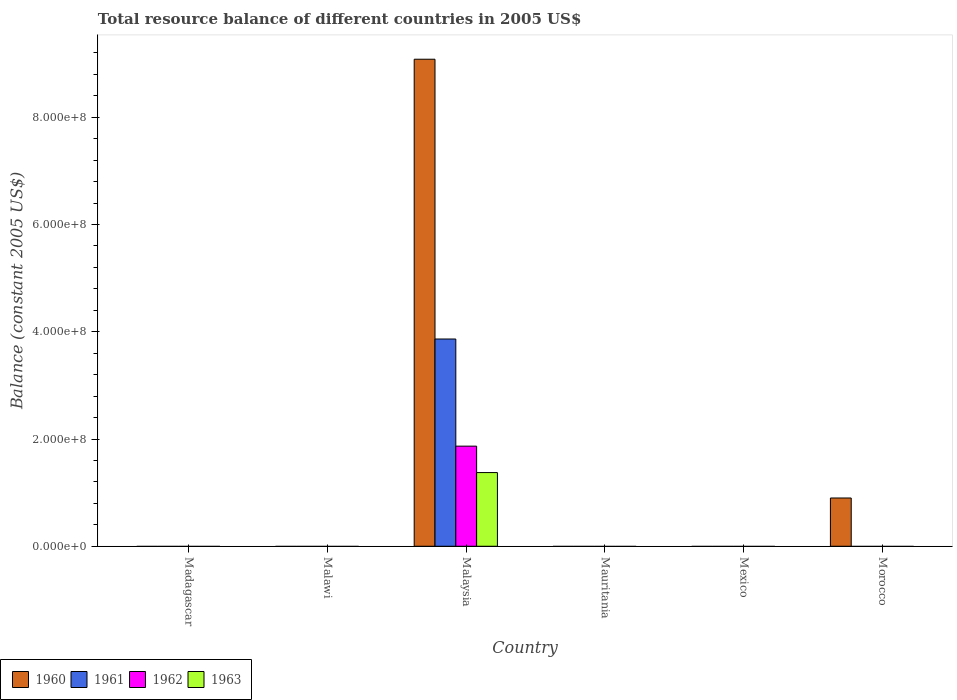Are the number of bars on each tick of the X-axis equal?
Your answer should be very brief. No. How many bars are there on the 1st tick from the left?
Give a very brief answer. 0. What is the label of the 1st group of bars from the left?
Provide a succinct answer. Madagascar. In how many cases, is the number of bars for a given country not equal to the number of legend labels?
Your response must be concise. 5. What is the total resource balance in 1960 in Morocco?
Provide a short and direct response. 9.00e+07. Across all countries, what is the maximum total resource balance in 1962?
Your response must be concise. 1.87e+08. Across all countries, what is the minimum total resource balance in 1962?
Your response must be concise. 0. In which country was the total resource balance in 1960 maximum?
Your answer should be compact. Malaysia. What is the total total resource balance in 1961 in the graph?
Your answer should be very brief. 3.87e+08. What is the average total resource balance in 1963 per country?
Your response must be concise. 2.29e+07. In how many countries, is the total resource balance in 1961 greater than 440000000 US$?
Your response must be concise. 0. What is the difference between the highest and the lowest total resource balance in 1961?
Your answer should be very brief. 3.87e+08. In how many countries, is the total resource balance in 1960 greater than the average total resource balance in 1960 taken over all countries?
Your answer should be compact. 1. Are all the bars in the graph horizontal?
Keep it short and to the point. No. How many countries are there in the graph?
Your answer should be compact. 6. What is the difference between two consecutive major ticks on the Y-axis?
Offer a very short reply. 2.00e+08. Are the values on the major ticks of Y-axis written in scientific E-notation?
Offer a terse response. Yes. Does the graph contain any zero values?
Give a very brief answer. Yes. Where does the legend appear in the graph?
Ensure brevity in your answer.  Bottom left. What is the title of the graph?
Give a very brief answer. Total resource balance of different countries in 2005 US$. What is the label or title of the Y-axis?
Your answer should be very brief. Balance (constant 2005 US$). What is the Balance (constant 2005 US$) of 1961 in Madagascar?
Provide a short and direct response. 0. What is the Balance (constant 2005 US$) in 1963 in Madagascar?
Your answer should be compact. 0. What is the Balance (constant 2005 US$) in 1960 in Malawi?
Your response must be concise. 0. What is the Balance (constant 2005 US$) in 1961 in Malawi?
Ensure brevity in your answer.  0. What is the Balance (constant 2005 US$) in 1960 in Malaysia?
Provide a succinct answer. 9.08e+08. What is the Balance (constant 2005 US$) in 1961 in Malaysia?
Offer a terse response. 3.87e+08. What is the Balance (constant 2005 US$) of 1962 in Malaysia?
Offer a very short reply. 1.87e+08. What is the Balance (constant 2005 US$) in 1963 in Malaysia?
Your answer should be compact. 1.37e+08. What is the Balance (constant 2005 US$) in 1962 in Mauritania?
Give a very brief answer. 0. What is the Balance (constant 2005 US$) in 1963 in Mauritania?
Offer a terse response. 0. What is the Balance (constant 2005 US$) in 1960 in Mexico?
Your answer should be compact. 0. What is the Balance (constant 2005 US$) in 1961 in Mexico?
Ensure brevity in your answer.  0. What is the Balance (constant 2005 US$) in 1962 in Mexico?
Make the answer very short. 0. What is the Balance (constant 2005 US$) in 1960 in Morocco?
Provide a succinct answer. 9.00e+07. What is the Balance (constant 2005 US$) of 1961 in Morocco?
Give a very brief answer. 0. What is the Balance (constant 2005 US$) in 1962 in Morocco?
Keep it short and to the point. 0. What is the Balance (constant 2005 US$) of 1963 in Morocco?
Provide a succinct answer. 0. Across all countries, what is the maximum Balance (constant 2005 US$) in 1960?
Make the answer very short. 9.08e+08. Across all countries, what is the maximum Balance (constant 2005 US$) of 1961?
Your response must be concise. 3.87e+08. Across all countries, what is the maximum Balance (constant 2005 US$) of 1962?
Your response must be concise. 1.87e+08. Across all countries, what is the maximum Balance (constant 2005 US$) in 1963?
Offer a very short reply. 1.37e+08. Across all countries, what is the minimum Balance (constant 2005 US$) of 1962?
Your answer should be compact. 0. Across all countries, what is the minimum Balance (constant 2005 US$) in 1963?
Ensure brevity in your answer.  0. What is the total Balance (constant 2005 US$) of 1960 in the graph?
Provide a succinct answer. 9.98e+08. What is the total Balance (constant 2005 US$) of 1961 in the graph?
Give a very brief answer. 3.87e+08. What is the total Balance (constant 2005 US$) of 1962 in the graph?
Offer a terse response. 1.87e+08. What is the total Balance (constant 2005 US$) in 1963 in the graph?
Ensure brevity in your answer.  1.37e+08. What is the difference between the Balance (constant 2005 US$) in 1960 in Malaysia and that in Morocco?
Ensure brevity in your answer.  8.18e+08. What is the average Balance (constant 2005 US$) in 1960 per country?
Offer a terse response. 1.66e+08. What is the average Balance (constant 2005 US$) in 1961 per country?
Your response must be concise. 6.44e+07. What is the average Balance (constant 2005 US$) in 1962 per country?
Your response must be concise. 3.11e+07. What is the average Balance (constant 2005 US$) of 1963 per country?
Give a very brief answer. 2.29e+07. What is the difference between the Balance (constant 2005 US$) in 1960 and Balance (constant 2005 US$) in 1961 in Malaysia?
Your response must be concise. 5.22e+08. What is the difference between the Balance (constant 2005 US$) of 1960 and Balance (constant 2005 US$) of 1962 in Malaysia?
Make the answer very short. 7.22e+08. What is the difference between the Balance (constant 2005 US$) in 1960 and Balance (constant 2005 US$) in 1963 in Malaysia?
Offer a very short reply. 7.71e+08. What is the difference between the Balance (constant 2005 US$) in 1961 and Balance (constant 2005 US$) in 1962 in Malaysia?
Make the answer very short. 2.00e+08. What is the difference between the Balance (constant 2005 US$) in 1961 and Balance (constant 2005 US$) in 1963 in Malaysia?
Provide a succinct answer. 2.49e+08. What is the difference between the Balance (constant 2005 US$) of 1962 and Balance (constant 2005 US$) of 1963 in Malaysia?
Your answer should be compact. 4.93e+07. What is the ratio of the Balance (constant 2005 US$) of 1960 in Malaysia to that in Morocco?
Keep it short and to the point. 10.09. What is the difference between the highest and the lowest Balance (constant 2005 US$) of 1960?
Make the answer very short. 9.08e+08. What is the difference between the highest and the lowest Balance (constant 2005 US$) in 1961?
Offer a terse response. 3.87e+08. What is the difference between the highest and the lowest Balance (constant 2005 US$) in 1962?
Your response must be concise. 1.87e+08. What is the difference between the highest and the lowest Balance (constant 2005 US$) in 1963?
Give a very brief answer. 1.37e+08. 